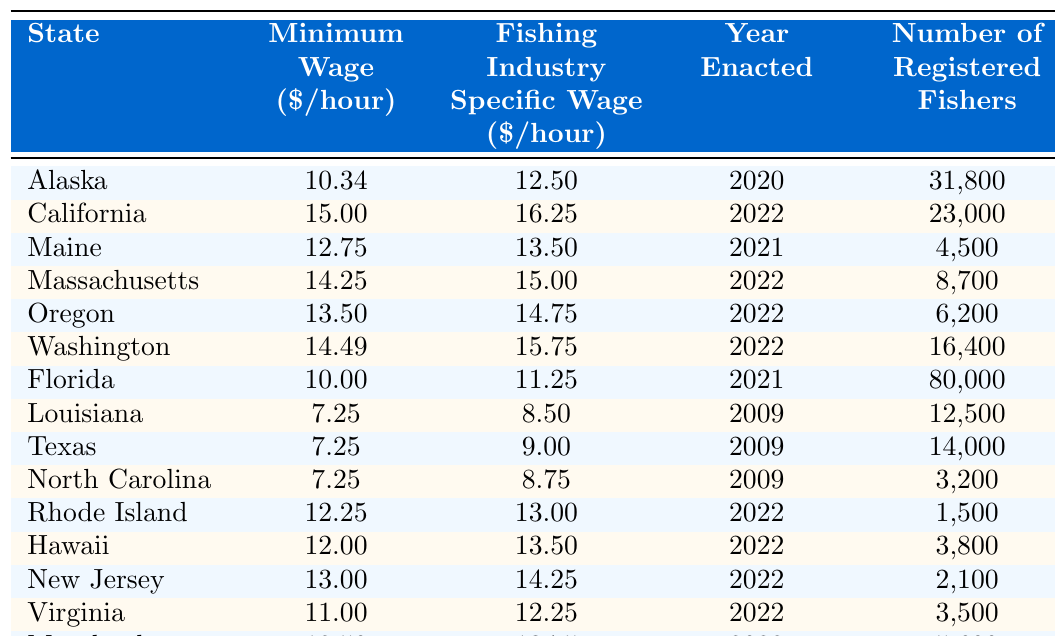What is the minimum wage for fishing industry workers in California? According to the table, California has a minimum wage of $15.00 per hour for fishing industry workers.
Answer: $15.00 Which state has the highest fishing industry specific wage? By examining the table, California has the highest fishing industry specific wage at $16.25 per hour compared to other states listed.
Answer: $16.25 What is the average fishing industry specific wage across all the states listed? To find the average, sum the fishing industry specific wages: (12.50 + 16.25 + 13.50 + 15.00 + 14.75 + 15.75 + 11.25 + 8.50 + 9.00 + 8.75 + 13.00 + 13.50 + 14.25 + 12.25 + 13.75) =  13.50, then divide by the number of states (15): 13.50 / 15 = 13.50.
Answer: $13.50 Is the minimum wage for fishing industry workers in Florida higher than the national average minimum wage? The table shows Florida's minimum wage is $10.00, and since the national minimum wage is often considered to be $7.25, $10.00 is indeed higher.
Answer: Yes How many states have a fishing industry specific wage greater than $14.00? Reviewing the table, the states with a fishing industry specific wage greater than $14.00 are California (16.25), Massachusetts (15.00), Washington (15.75), and Oregon (14.75), which totals four states.
Answer: 4 What is the difference in minimum wage between Alaska and Louisiana? The minimum wage in Alaska is $10.34 and in Louisiana, it is $7.25. The difference is $10.34 - $7.25 = $3.09.
Answer: $3.09 How many registered fishers are there in Maine and Rhode Island combined? The number of registered fishers in Maine is 4,500 and in Rhode Island is 1,500. Summing these gives: 4,500 + 1,500 = 6,000.
Answer: 6,000 Is the fishing industry specific wage in Texas greater than the minimum wage in Louisiana? Texas has a fishing industry specific wage of $9.00 and Louisiana has a minimum wage of $7.25. Since $9.00 is greater than $7.25, the statement is true.
Answer: Yes Which state has the lowest minimum wage in the table? By comparing all minimum wages listed, Louisiana and Texas both have the lowest minimum wage at $7.25 per hour.
Answer: Louisiana and Texas Which states enacted their fishing industry specific wages in the year 2022? The states that enacted fishing industry specific wages in 2022 are California, Massachusetts, Oregon, Washington, Rhode Island, Hawaii, New Jersey, and Virginia, totaling eight states.
Answer: 8 What is the total number of registered fishers in Alaska, Florida, and California? Adding the registered fishers: Alaska (31,800) + Florida (80,000) + California (23,000) gives a total of 31,800 + 80,000 + 23,000 = 134,800.
Answer: 134,800 